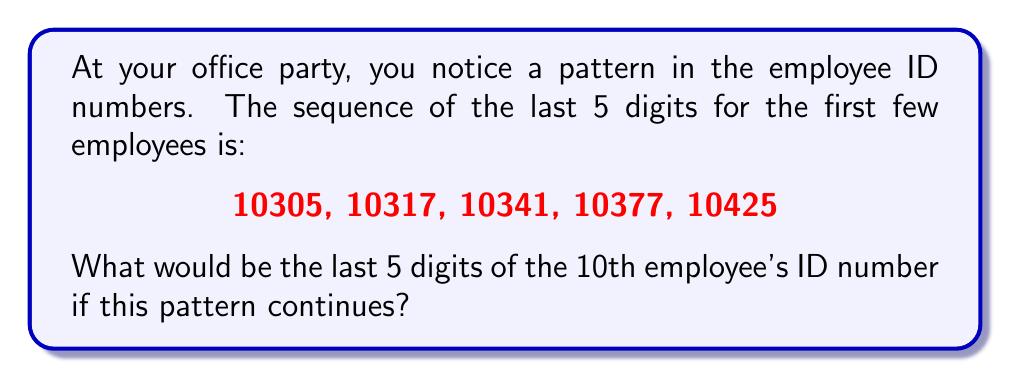Can you answer this question? Let's approach this step-by-step:

1) First, let's find the difference between each consecutive number:
   10305 to 10317: 12
   10317 to 10341: 24
   10341 to 10377: 36
   10377 to 10425: 48

2) We can see that the difference is increasing by 12 each time:
   12, 24, 36, 48

3) This forms an arithmetic sequence with a common difference of 12.

4) We can express this as a formula:
   $d_n = 12n$, where $n$ is the position in the sequence of differences.

5) Now, let's continue this pattern for the next differences:
   5th difference: $12 * 5 = 60$
   6th difference: $12 * 6 = 72$
   7th difference: $12 * 7 = 84$
   8th difference: $12 * 8 = 96$
   9th difference: $12 * 9 = 108$

6) Now, let's add these differences to our last known number (10425):
   6th number: $10425 + 60 = 10485$
   7th number: $10485 + 72 = 10557$
   8th number: $10557 + 84 = 10641$
   9th number: $10641 + 96 = 10737$
   10th number: $10737 + 108 = 10845$

Therefore, the 10th employee's ID number would end in 10845.
Answer: 10845 